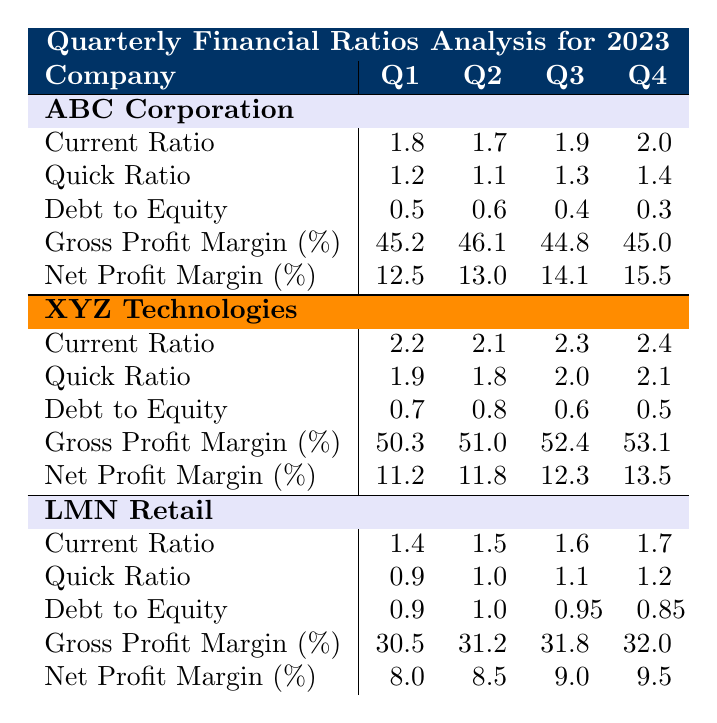What is the current ratio for ABC Corporation in Q4 2023? The table shows that for ABC Corporation in Q4 2023, the current ratio is 2.0.
Answer: 2.0 Which company had the highest current ratio in Q1 2023? According to the table, XYZ Technologies had the highest current ratio in Q1 2023 at 2.2.
Answer: XYZ Technologies What is the average net profit margin for LMN Retail in 2023? Adding the net profit margins for LMN Retail across the four quarters gives (8.0 + 8.5 + 9.0 + 9.5) = 35.0. Dividing by 4 results in an average of 35.0/4 = 8.75.
Answer: 8.75 Did ABC Corporation improve its debt to equity ratio from Q1 to Q4 2023? The debt to equity ratio for ABC Corporation went from 0.5 in Q1 to 0.3 in Q4, indicating an improvement.
Answer: Yes What was the change in gross profit margin for XYZ Technologies from Q1 to Q4 2023? The gross profit margin changed from 50.3 in Q1 to 53.1 in Q4, which is an increase of 53.1 - 50.3 = 2.8.
Answer: 2.8 Which company has the highest debt to equity ratio in Q2 2023? In Q2 2023, LMN Retail has the highest debt to equity ratio at 1.0 compared to the other companies.
Answer: LMN Retail What was the difference in quick ratio between ABC Corporation and XYZ Technologies in Q3 2023? In Q3 2023, ABC Corporation's quick ratio is 1.3 and XYZ Technologies' quick ratio is 2.0. The difference is 2.0 - 1.3 = 0.7.
Answer: 0.7 Which company consistently had the highest gross profit margin throughout 2023? The table indicates that XYZ Technologies had the highest gross profit margin each quarter, starting at 50.3% and ending at 53.1%.
Answer: XYZ Technologies What is the trend in current ratio for LMN Retail over the four quarters? The current ratio for LMN Retail increased from 1.4 in Q1 to 1.7 in Q4, showing a positive trend over the year.
Answer: Increasing In Q2 2023, what is the average quick ratio of all companies listed? The quick ratios in Q2 are 1.1 (ABC), 1.8 (XYZ), and 1.0 (LMN). Adding these gives 1.1 + 1.8 + 1.0 = 3.9, which divided by 3 results in an average of 3.9 / 3 = 1.3.
Answer: 1.3 